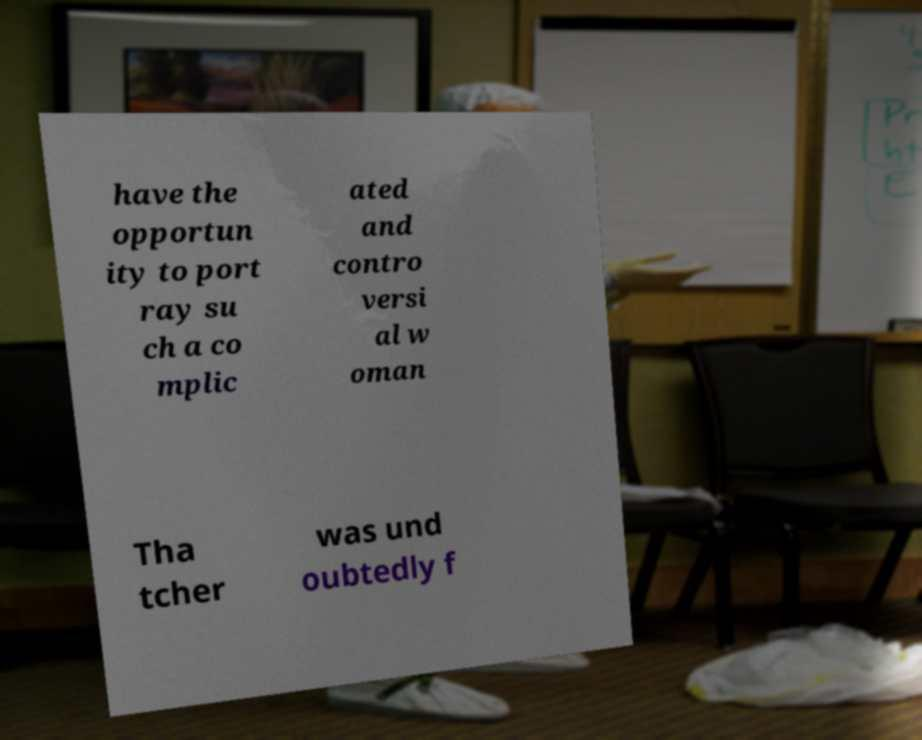Could you extract and type out the text from this image? have the opportun ity to port ray su ch a co mplic ated and contro versi al w oman Tha tcher was und oubtedly f 